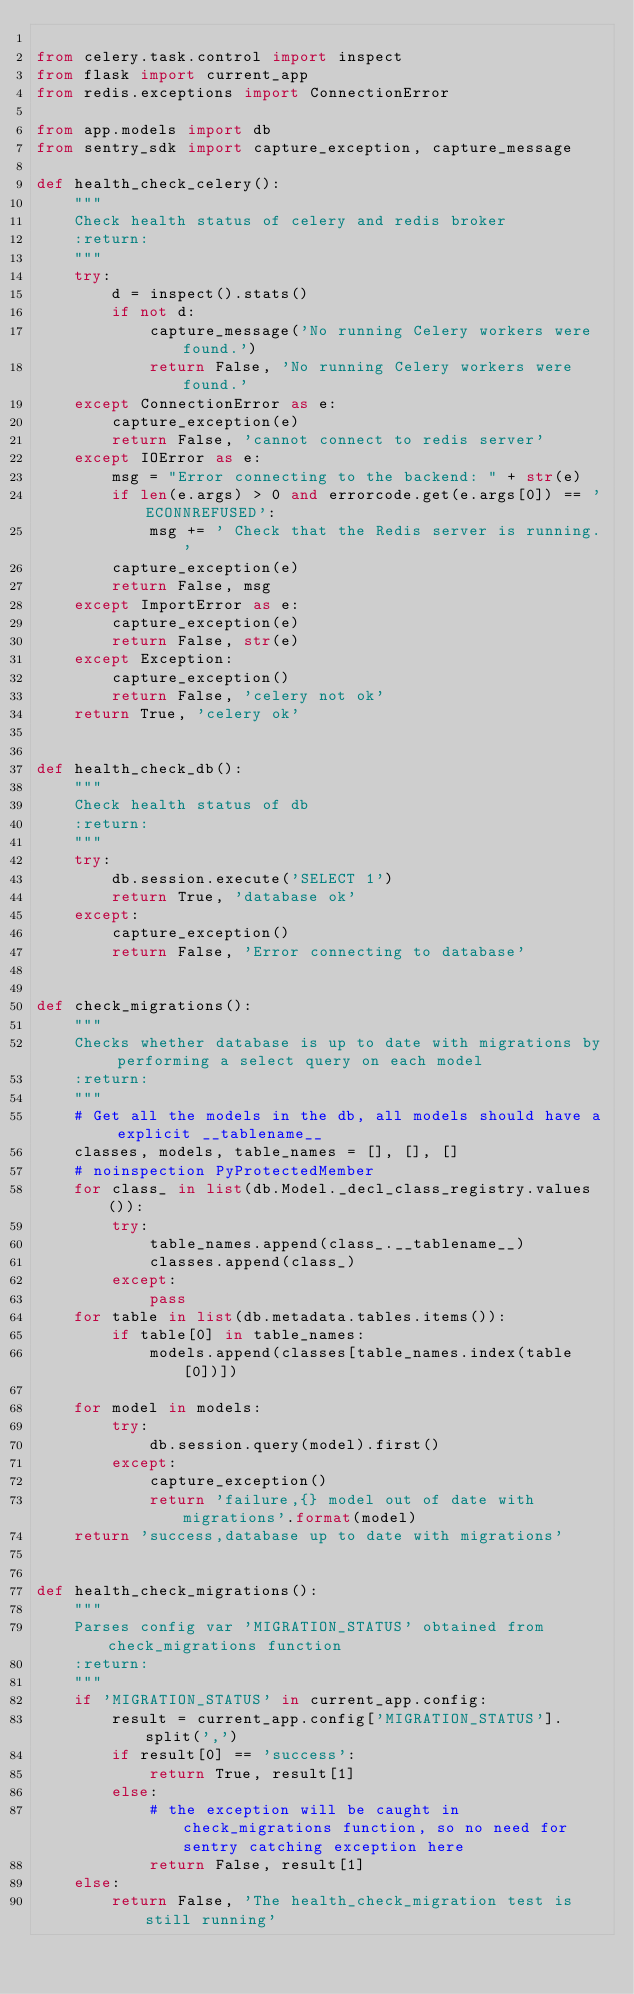<code> <loc_0><loc_0><loc_500><loc_500><_Python_>
from celery.task.control import inspect
from flask import current_app
from redis.exceptions import ConnectionError

from app.models import db
from sentry_sdk import capture_exception, capture_message

def health_check_celery():
    """
    Check health status of celery and redis broker
    :return:
    """
    try:
        d = inspect().stats()
        if not d:
            capture_message('No running Celery workers were found.')
            return False, 'No running Celery workers were found.'
    except ConnectionError as e:
        capture_exception(e)
        return False, 'cannot connect to redis server'
    except IOError as e:
        msg = "Error connecting to the backend: " + str(e)
        if len(e.args) > 0 and errorcode.get(e.args[0]) == 'ECONNREFUSED':
            msg += ' Check that the Redis server is running.'
        capture_exception(e)
        return False, msg
    except ImportError as e:
        capture_exception(e)
        return False, str(e)
    except Exception:
        capture_exception()
        return False, 'celery not ok'
    return True, 'celery ok'


def health_check_db():
    """
    Check health status of db
    :return:
    """
    try:
        db.session.execute('SELECT 1')
        return True, 'database ok'
    except:
        capture_exception()
        return False, 'Error connecting to database'


def check_migrations():
    """
    Checks whether database is up to date with migrations by performing a select query on each model
    :return:
    """
    # Get all the models in the db, all models should have a explicit __tablename__
    classes, models, table_names = [], [], []
    # noinspection PyProtectedMember
    for class_ in list(db.Model._decl_class_registry.values()):
        try:
            table_names.append(class_.__tablename__)
            classes.append(class_)
        except:
            pass
    for table in list(db.metadata.tables.items()):
        if table[0] in table_names:
            models.append(classes[table_names.index(table[0])])

    for model in models:
        try:
            db.session.query(model).first()
        except:
            capture_exception()
            return 'failure,{} model out of date with migrations'.format(model)
    return 'success,database up to date with migrations'


def health_check_migrations():
    """
    Parses config var 'MIGRATION_STATUS' obtained from check_migrations function
    :return:
    """
    if 'MIGRATION_STATUS' in current_app.config:
        result = current_app.config['MIGRATION_STATUS'].split(',')
        if result[0] == 'success':
            return True, result[1]
        else:
            # the exception will be caught in check_migrations function, so no need for sentry catching exception here
            return False, result[1]
    else:
        return False, 'The health_check_migration test is still running'
</code> 